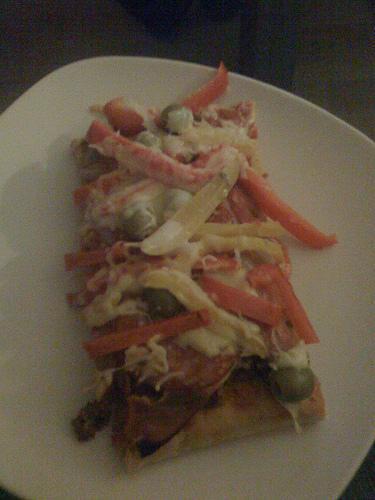How many plates are in the picture?
Give a very brief answer. 1. 